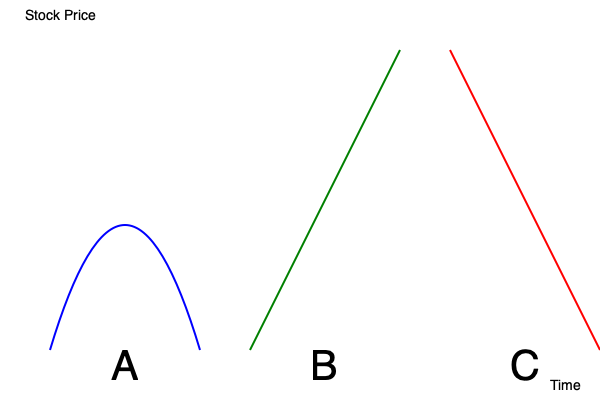As a fundamental analyst, match the following stock price trends to their corresponding chart shapes (A, B, or C):

1. Bullish trend
2. Bearish trend
3. Mean reversion To match the stock price trends with their corresponding chart shapes, let's analyze each chart and trend:

1. Bullish trend:
   - A bullish trend is characterized by rising stock prices over time.
   - Looking at the charts, we can see that Chart B shows a consistent upward movement from left to right.
   - This represents a bullish trend, as the stock price is increasing over time.

2. Bearish trend:
   - A bearish trend is characterized by falling stock prices over time.
   - Examining the charts, we can observe that Chart C displays a downward movement from left to right.
   - This represents a bearish trend, as the stock price is decreasing over time.

3. Mean reversion:
   - Mean reversion is a theory suggesting that asset prices and other market indicators tend to move back towards the mean or average over time.
   - Chart A shows a pattern where the price starts at a certain level, drops significantly, and then returns to approximately the same level.
   - This U-shaped pattern is characteristic of mean reversion, where the price deviates from its average but eventually returns to it.

Therefore, the matching is as follows:
1. Bullish trend - Chart B
2. Bearish trend - Chart C
3. Mean reversion - Chart A
Answer: 1-B, 2-C, 3-A 